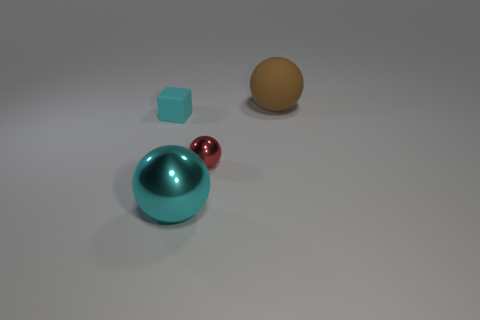Add 4 tiny objects. How many objects exist? 8 Subtract all cubes. How many objects are left? 3 Subtract 0 gray blocks. How many objects are left? 4 Subtract all large brown matte things. Subtract all tiny green objects. How many objects are left? 3 Add 3 small shiny objects. How many small shiny objects are left? 4 Add 3 yellow matte spheres. How many yellow matte spheres exist? 3 